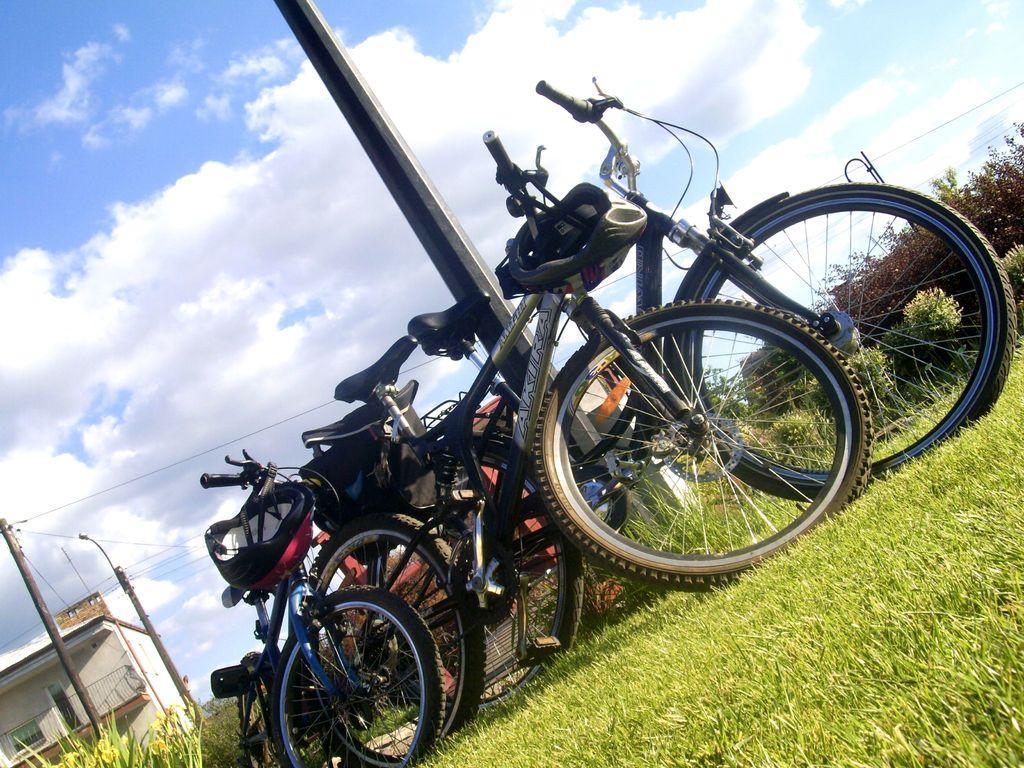How would you summarize this image in a sentence or two? In the image we can see there are many bicycles and there is a helmet. This is a grass, pole, electric pole, electric wires, plant, building and a cloudy sky. 